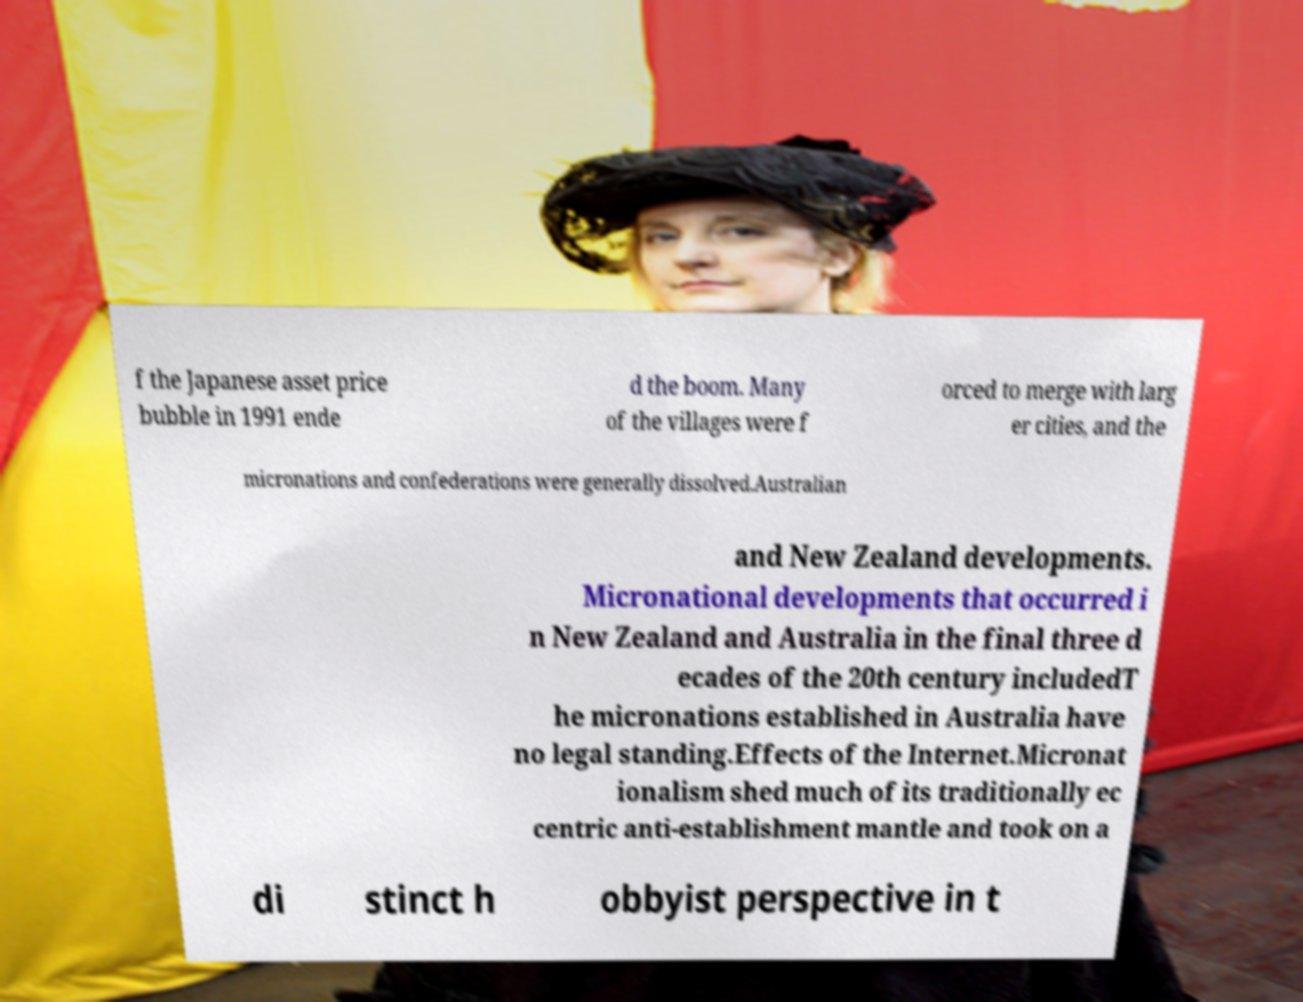I need the written content from this picture converted into text. Can you do that? f the Japanese asset price bubble in 1991 ende d the boom. Many of the villages were f orced to merge with larg er cities, and the micronations and confederations were generally dissolved.Australian and New Zealand developments. Micronational developments that occurred i n New Zealand and Australia in the final three d ecades of the 20th century includedT he micronations established in Australia have no legal standing.Effects of the Internet.Micronat ionalism shed much of its traditionally ec centric anti-establishment mantle and took on a di stinct h obbyist perspective in t 